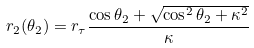Convert formula to latex. <formula><loc_0><loc_0><loc_500><loc_500>r _ { 2 } ( \theta _ { 2 } ) = r _ { \tau } \frac { \cos \theta _ { 2 } + \sqrt { \cos ^ { 2 } \theta _ { 2 } + \kappa ^ { 2 } } } { \kappa }</formula> 